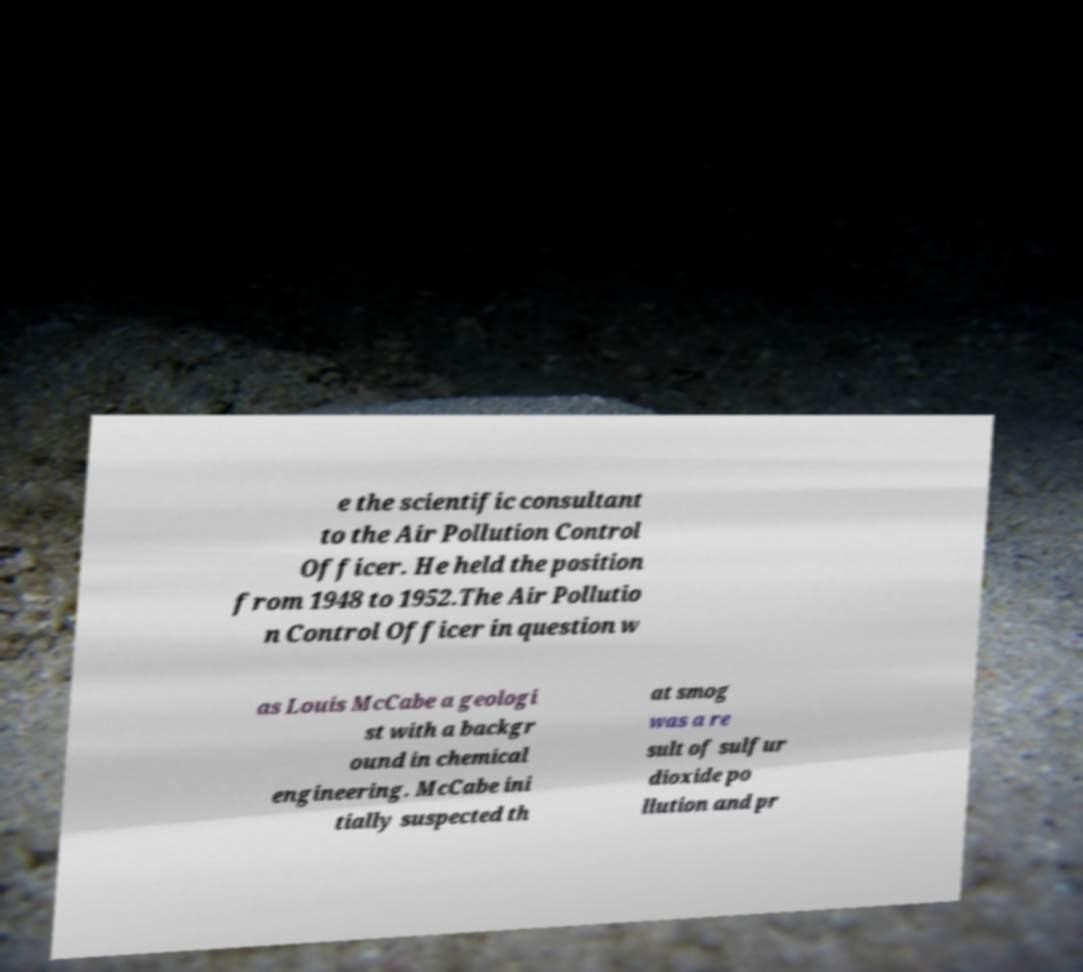Could you assist in decoding the text presented in this image and type it out clearly? e the scientific consultant to the Air Pollution Control Officer. He held the position from 1948 to 1952.The Air Pollutio n Control Officer in question w as Louis McCabe a geologi st with a backgr ound in chemical engineering. McCabe ini tially suspected th at smog was a re sult of sulfur dioxide po llution and pr 